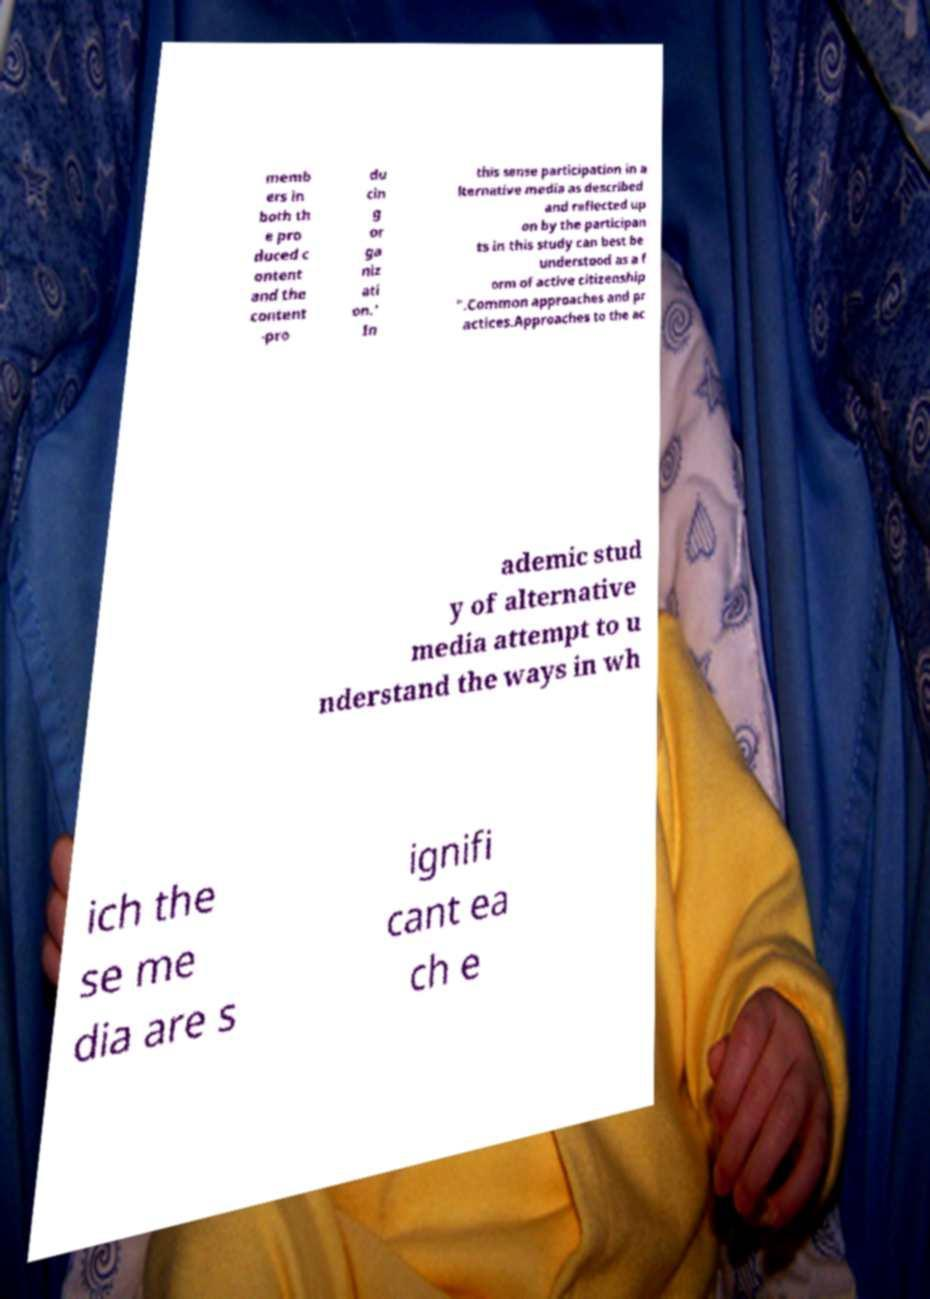I need the written content from this picture converted into text. Can you do that? memb ers in both th e pro duced c ontent and the content -pro du cin g or ga niz ati on.’ In this sense participation in a lternative media as described and reflected up on by the participan ts in this study can best be understood as a f orm of active citizenship ".Common approaches and pr actices.Approaches to the ac ademic stud y of alternative media attempt to u nderstand the ways in wh ich the se me dia are s ignifi cant ea ch e 